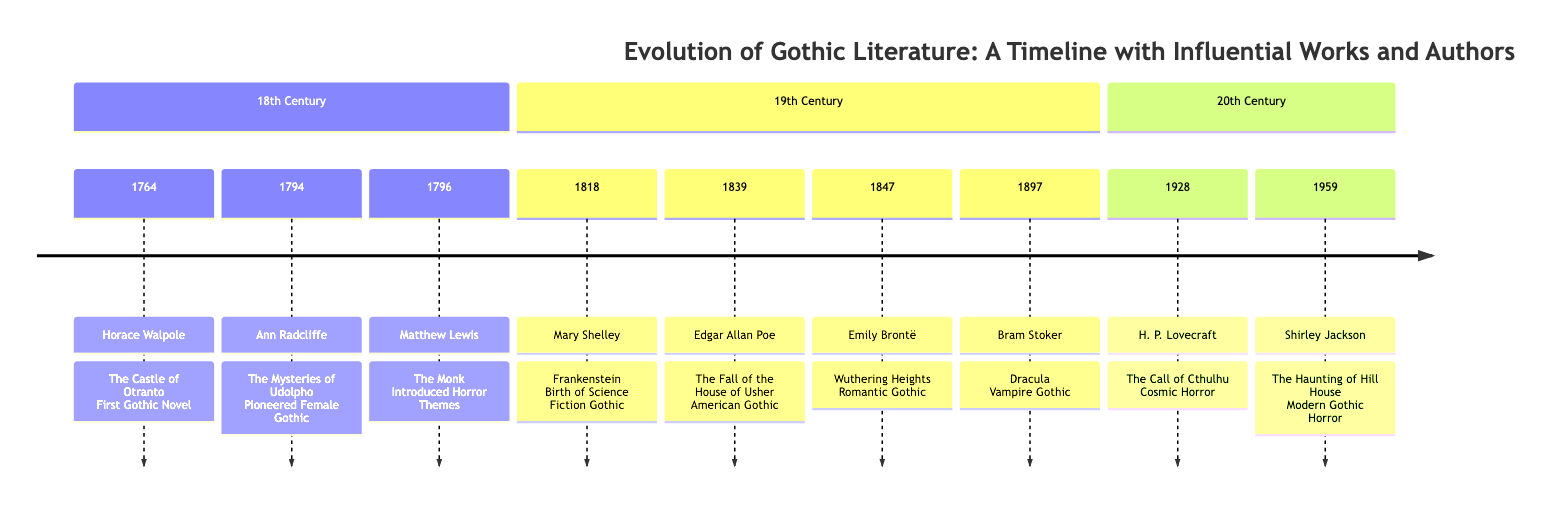What is the first Gothic novel? The timeline indicates that the first Gothic novel is "The Castle of Otranto," which was written by Horace Walpole in 1764.
Answer: The Castle of Otranto Which author pioneered the Female Gothic? According to the timeline, Ann Radcliffe is credited with pioneering the Female Gothic through her work "The Mysteries of Udolpho," published in 1794.
Answer: Ann Radcliffe How many influential works are listed for the 19th century? Reviewing the 19th-century section of the timeline, there are four influential works listed: "Frankenstein," "The Fall of the House of Usher," "Wuthering Heights," and "Dracula."
Answer: 4 Which work is considered the birth of Science Fiction Gothic? The timeline notes that Mary Shelley's "Frankenstein," published in 1818, is recognized as the birth of Science Fiction Gothic.
Answer: Frankenstein What year was "The Call of Cthulhu" published? The timeline specifies that H. P. Lovecraft's "The Call of Cthulhu" was published in 1928.
Answer: 1928 Which two authors contributed to the American Gothic genre? The timeline indicates that Edgar Allan Poe, with "The Fall of the House of Usher," and H. P. Lovecraft, with "The Call of Cthulhu," are the authors contributing to the American Gothic genre.
Answer: Edgar Allan Poe and H. P. Lovecraft What type of Gothic literature is "Dracula"? According to the diagram, Bram Stoker's "Dracula," published in 1897, is classified as Vampire Gothic.
Answer: Vampire Gothic Which work introduced horror themes? The timeline indicates that "The Monk," written by Matthew Lewis in 1796, is recognized for introducing horror themes into Gothic literature.
Answer: The Monk What significant change is noted in the 20th century regarding Gothic literature? The timeline shows that the 20th century introduced Modern Gothic Horror, as exemplified by Shirley Jackson's "The Haunting of Hill House," published in 1959, signifying a shift in the style of Gothic literature.
Answer: Modern Gothic Horror 